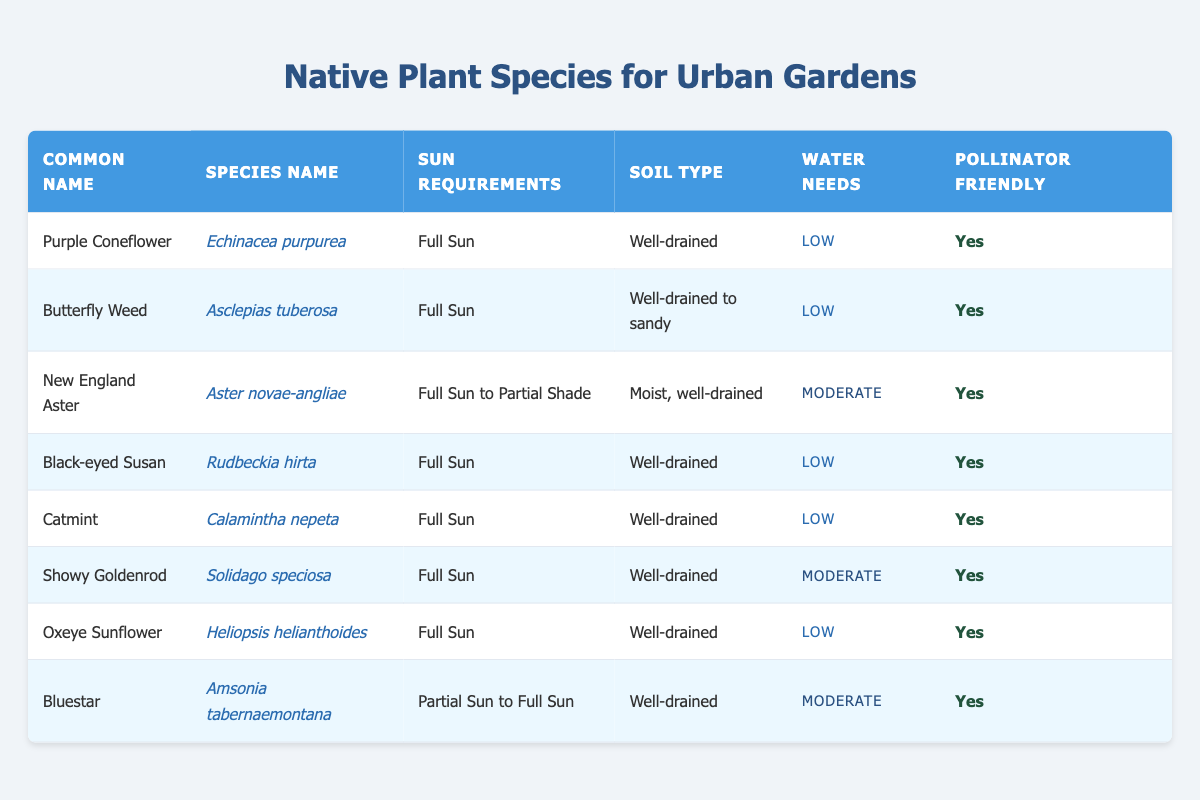What is the common name of Echinacea purpurea? The table lists "Echinacea purpurea" in the species name column, and the corresponding common name in the same row is "Purple Coneflower."
Answer: Purple Coneflower Which plants have low water needs? By scanning the water needs column, we find that "Echinacea purpurea," "Asclepias tuberosa," "Rudbeckia hirta," "Calamintha nepeta," and "Heliopsis helianthoides" all show "Low" water needs.
Answer: Echinacea purpurea, Asclepias tuberosa, Rudbeckia hirta, Calamintha nepeta, Heliopsis helianthoides How many plants are suitable for full sun? We evaluate the sun requirements column and count all species listed as "Full Sun." There are 6 species with this requirement: Echinacea purpurea, Asclepias tuberosa, Rudbeckia hirta, Calamintha nepeta, Solidago speciosa, and Heliopsis helianthoides.
Answer: 6 Is the New England Aster pollinator friendly? The table shows "Yes" under the pollinator friendly column for New England Aster, confirming that it is indeed friendly to pollinators.
Answer: Yes Which plant has moderate water needs and partial sun requirements? The only plant listed under both conditions is "Amsonia tabernaemontana," as it is specified to have "Moderate" water needs and "Partial Sun to Full Sun" sunlight.
Answer: Amsonia tabernaemontana What is the soil type for the Butterfly Weed? The table indicates that "Asclepias tuberosa," or Butterfly Weed, requires "Well-drained to sandy" soil type, based on the corresponding entry in the soil type column.
Answer: Well-drained to sandy How many plants require moist soil? By looking at the soil type column, there is one species that requires moist soil: Aster novae-angliae (New England Aster). Thus, the count is 1.
Answer: 1 Which plant has the highest water needs? The table shows that "Aster novae-angliae" and "Solidago speciosa" both require "Moderate" water needs, while all others listed require "Low," making these two the highest in terms of water necessity.
Answer: Aster novae-angliae, Solidago speciosa Are all the listed plants pollinator friendly? All entries in the pollinator friendly column indicate "Yes," confirming that every plant listed is suitable for pollinators.
Answer: Yes 